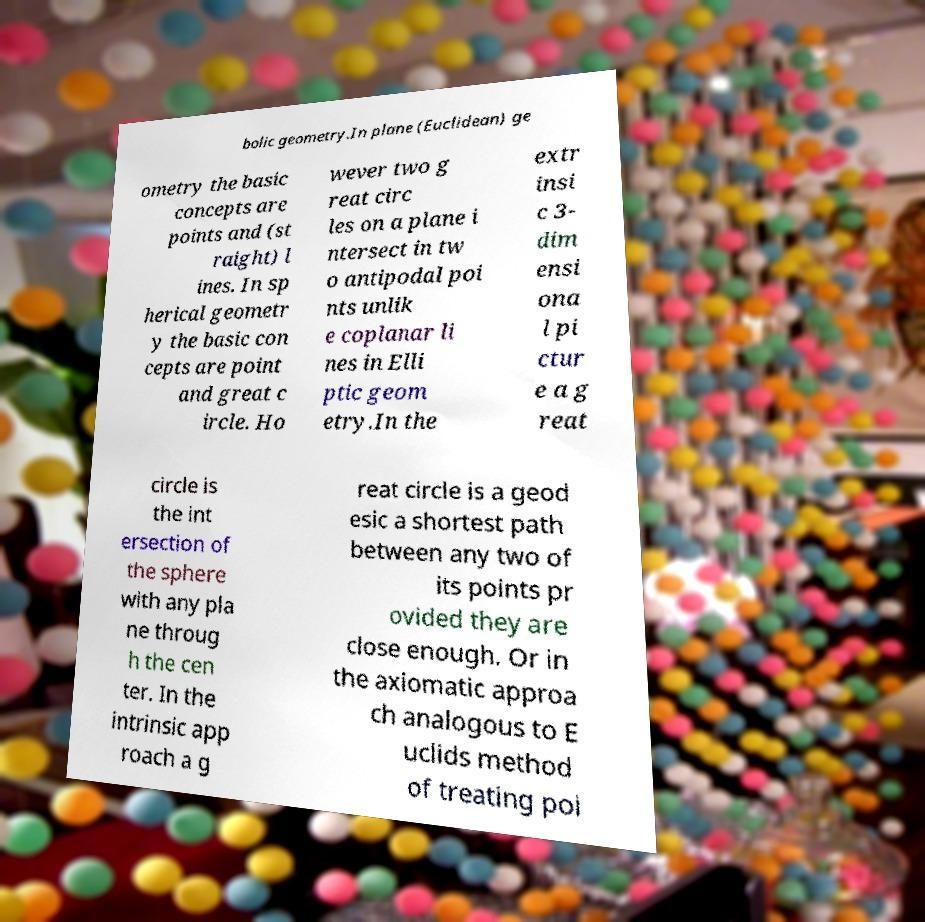Could you extract and type out the text from this image? bolic geometry.In plane (Euclidean) ge ometry the basic concepts are points and (st raight) l ines. In sp herical geometr y the basic con cepts are point and great c ircle. Ho wever two g reat circ les on a plane i ntersect in tw o antipodal poi nts unlik e coplanar li nes in Elli ptic geom etry.In the extr insi c 3- dim ensi ona l pi ctur e a g reat circle is the int ersection of the sphere with any pla ne throug h the cen ter. In the intrinsic app roach a g reat circle is a geod esic a shortest path between any two of its points pr ovided they are close enough. Or in the axiomatic approa ch analogous to E uclids method of treating poi 